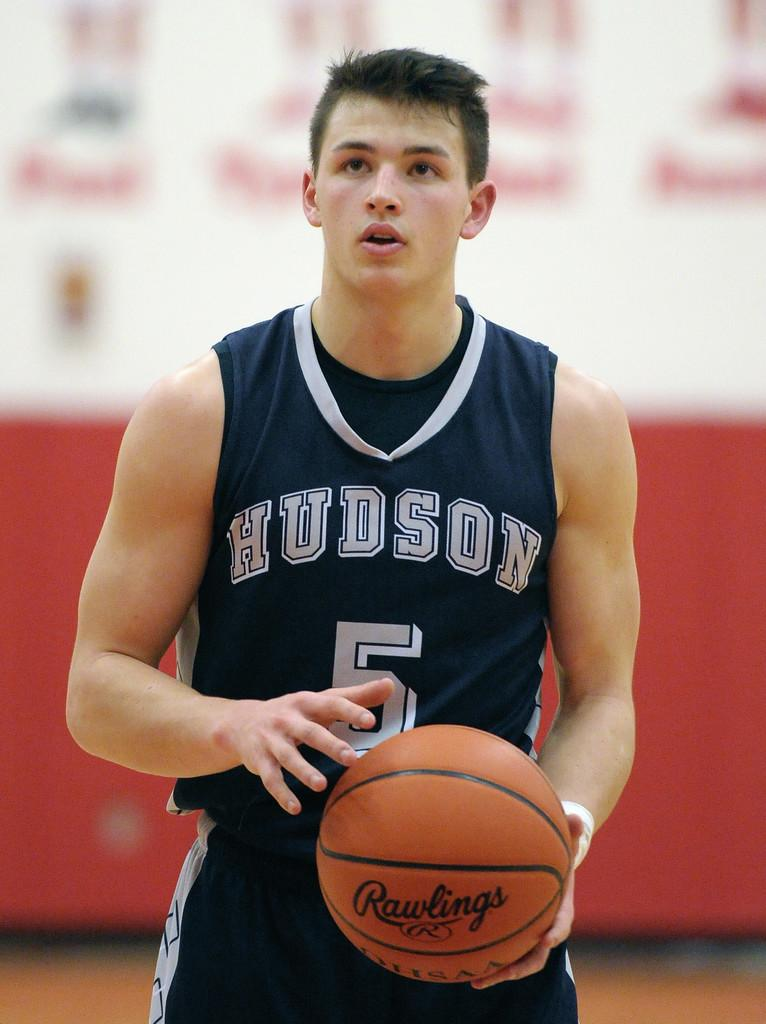<image>
Present a compact description of the photo's key features. A Hudson basketball player is holding a basketball. 